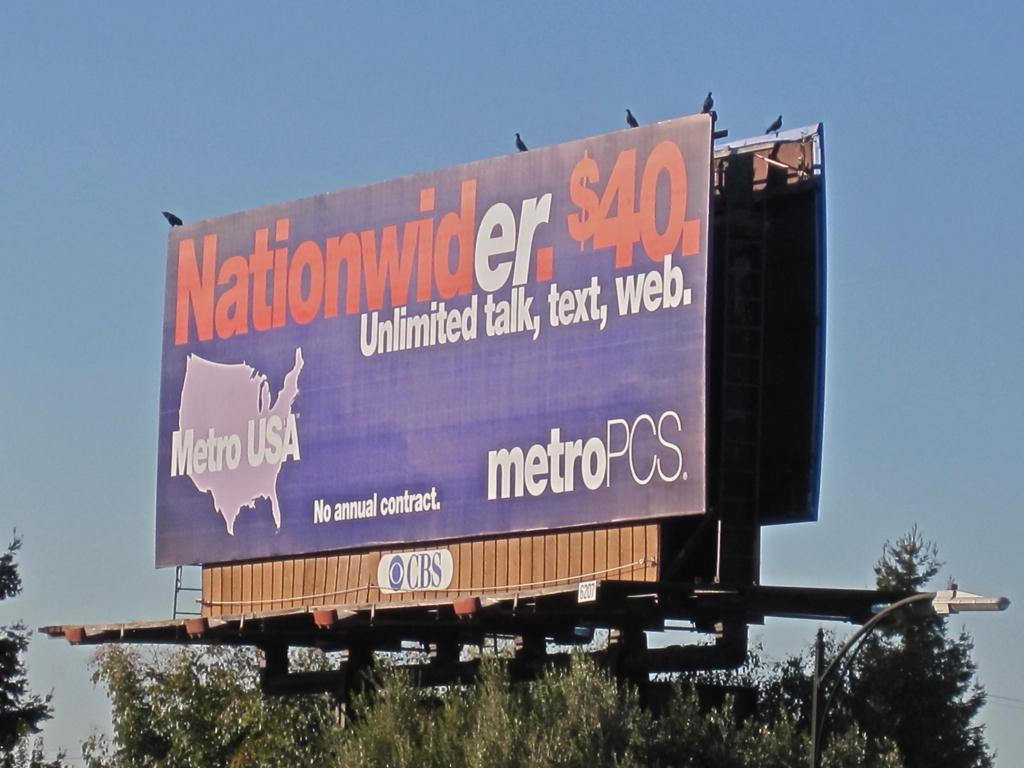<image>
Create a compact narrative representing the image presented. A blue billboard advertises a metroPCS plan that is just $40. 